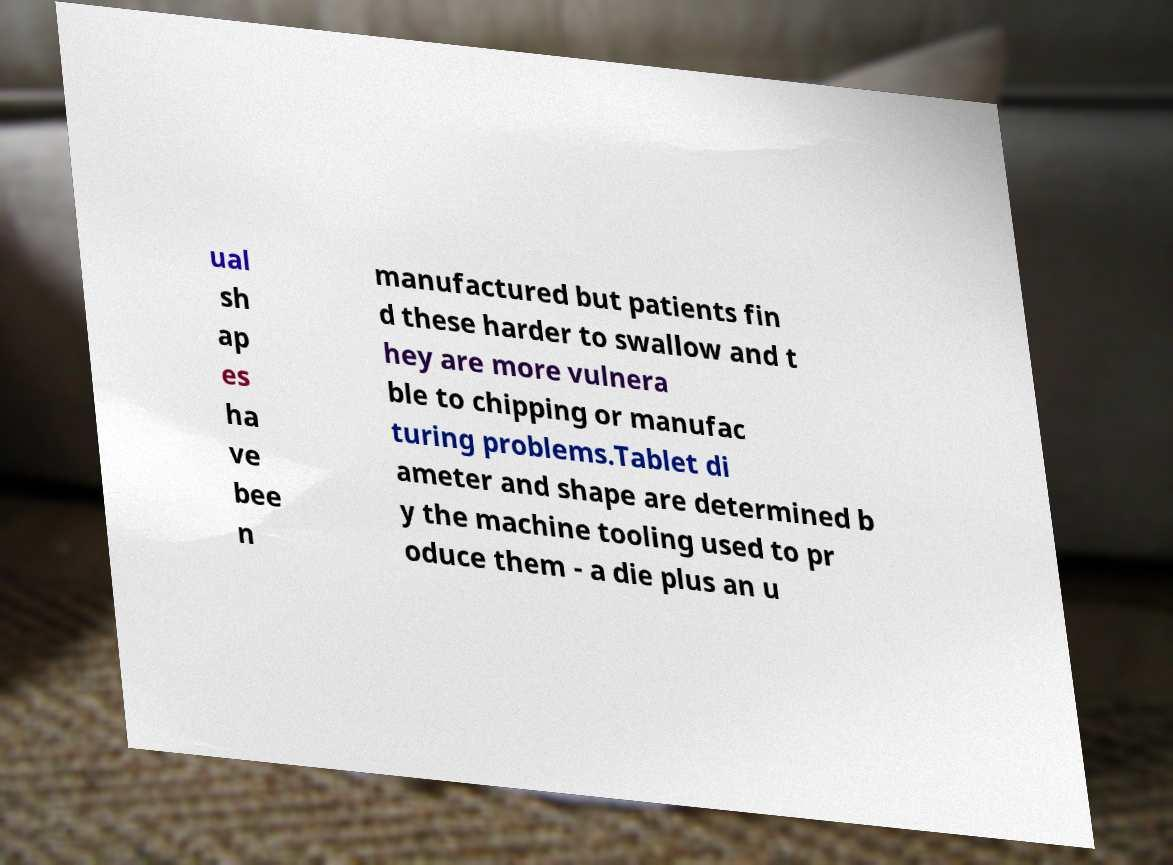Please read and relay the text visible in this image. What does it say? ual sh ap es ha ve bee n manufactured but patients fin d these harder to swallow and t hey are more vulnera ble to chipping or manufac turing problems.Tablet di ameter and shape are determined b y the machine tooling used to pr oduce them - a die plus an u 